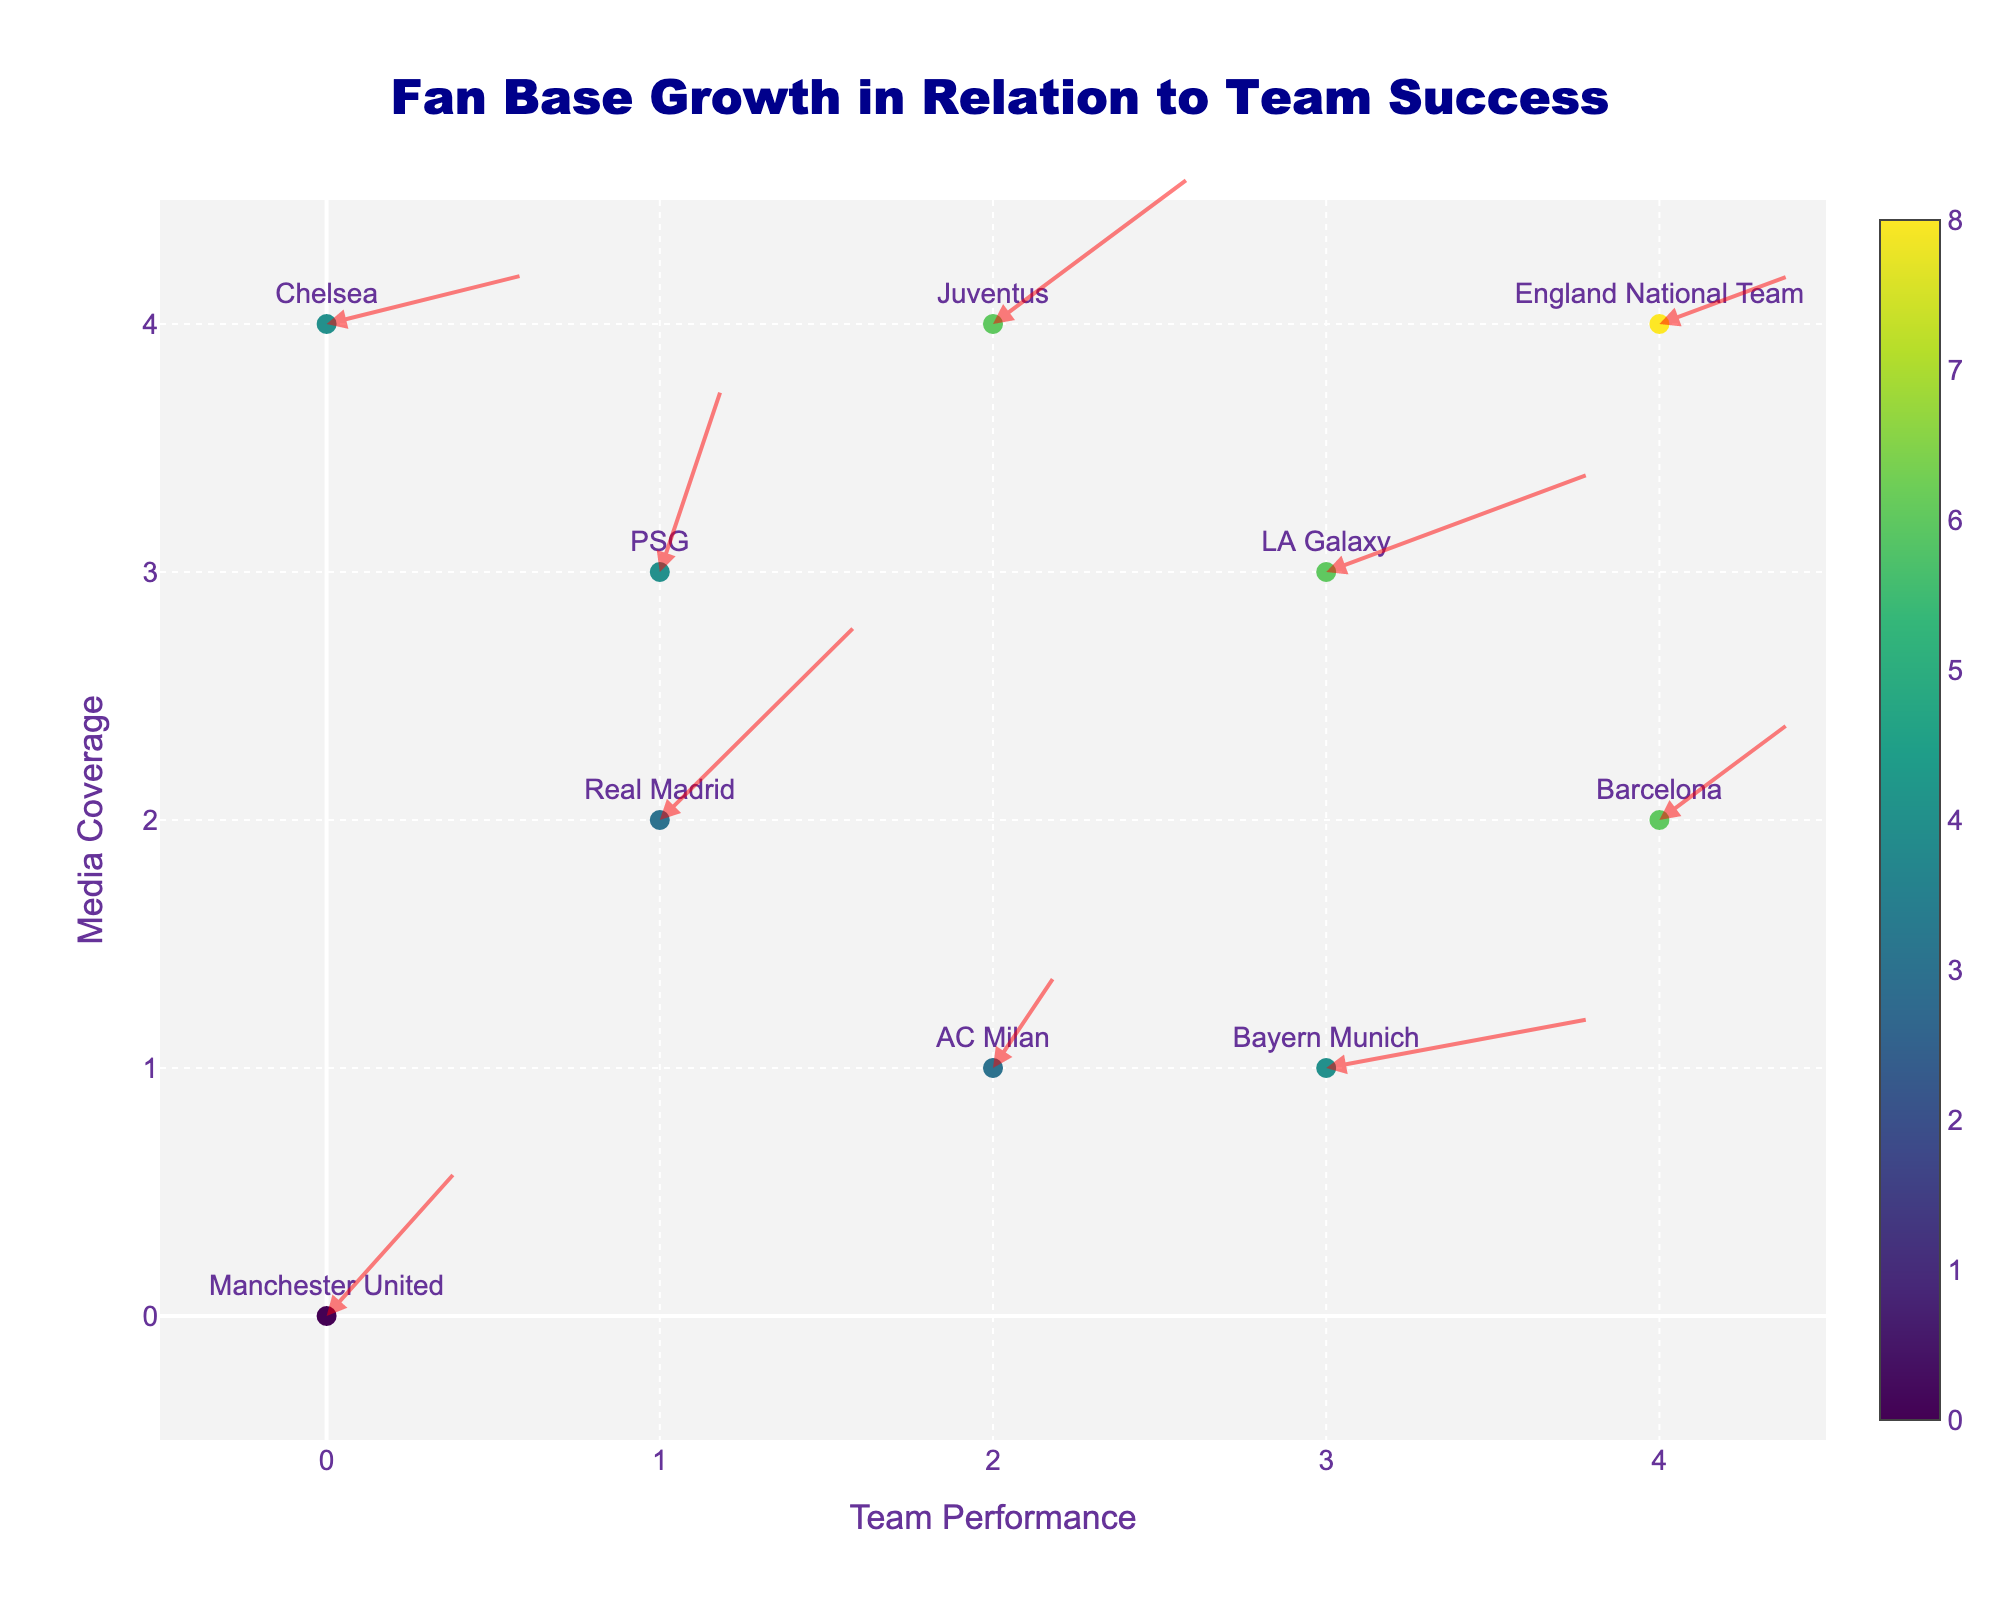How many data points are in the quiver plot? Count the number of data points shown on the quiver plot. Each point corresponds to a team.
Answer: 10 What is the title of the quiver plot? The title is usually displayed at the top of the plot.
Answer: Fan Base Growth in Relation to Team Success Which team has the highest media coverage and what was their achievement? Locate the point with the highest 'Y' value (Media Coverage) and check the corresponding team and their achievement.
Answer: PSG, Ligue 1 Title What color scale is used for the markers in the quiver plot? The color of the markers is described in the plot legend. In this case, it's a gradient.
Answer: Viridis Which team shows the fastest fan base growth corresponding to a Premier League Title? Find the annotation where the arrow represents the fastest growth, marked with "Premier League Title" achievement.
Answer: Manchester United What is the overall trend in fan base growth for the team with an MLS Cup Victory? Observe the direction and length of the arrow associated with "LA Galaxy" to understand the trend in growth.
Answer: Upward Which team has the second-highest fan base growth velocity? Look at the direction and length of the arrows. The second longest after identifying the longest arrow. Compare and identify the team.
Answer: Juventus What is the relationship between media coverage and fan base growth velocity in most teams? Compare the Y-values (media coverage) and the length/direction of arrows (growth velocity) to establish a general trend.
Answer: Positive correlation Which team's fan base growth direction is predominantly horizontal? What was their achievement? Identify the arrow which is mostly horizontal. Check the corresponding team and their achievement.
Answer: Bayern Munich, Bundesliga Record 